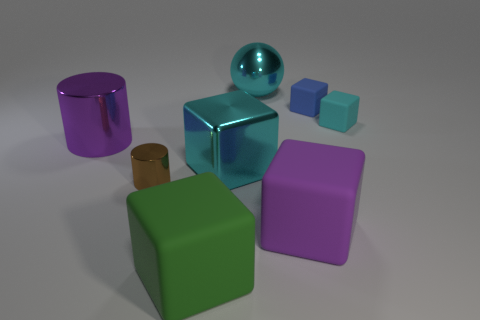Can you tell me more about the lighting in this scene? The scene is lit from above, which is evident from the shadows cast directly beneath the objects. The lighting appears soft and diffuse, creating gentle gradations of light and shadow on the surfaces without harsh contrasts, suggesting an indoor setting with controlled lighting conditions. 